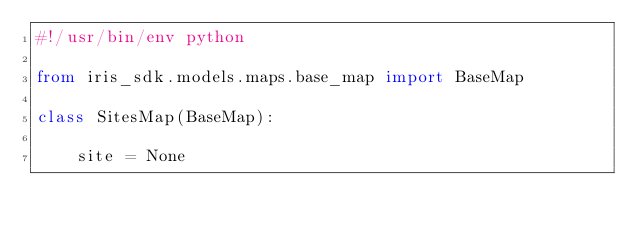Convert code to text. <code><loc_0><loc_0><loc_500><loc_500><_Python_>#!/usr/bin/env python

from iris_sdk.models.maps.base_map import BaseMap

class SitesMap(BaseMap):

    site = None</code> 